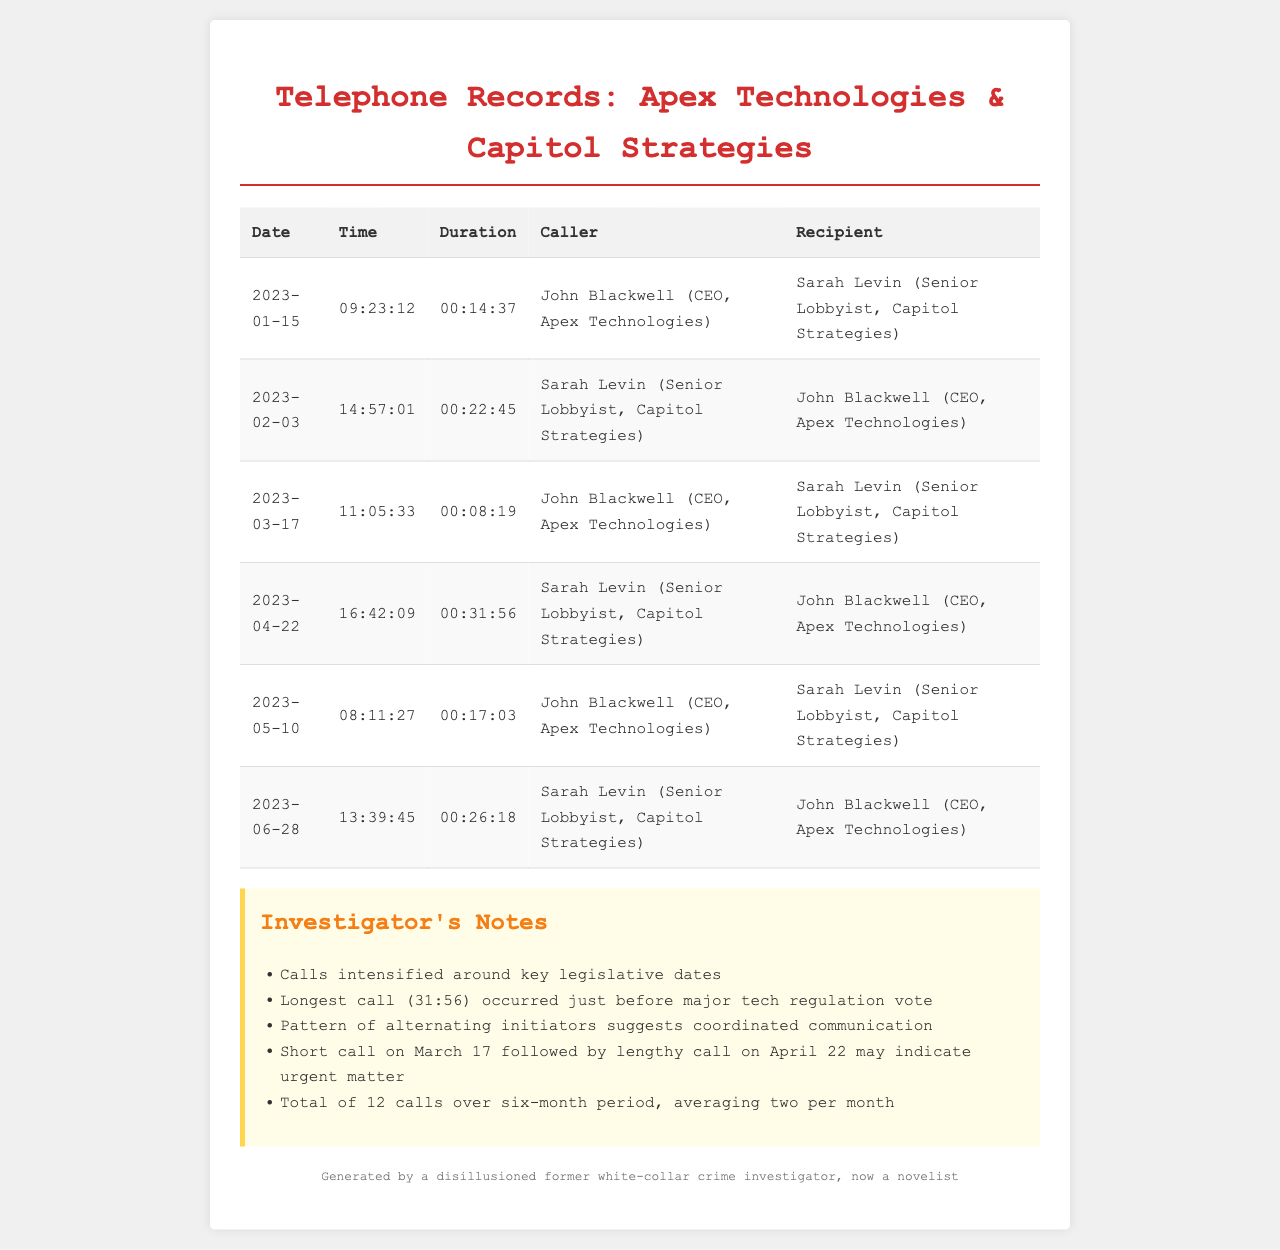What is the date of the longest call? The longest call lasted 31 minutes and 56 seconds, which occurred on April 22, 2023.
Answer: April 22, 2023 Who is the CEO of Apex Technologies? The document states that John Blackwell holds the title of CEO at Apex Technologies.
Answer: John Blackwell How many calls were made in total over the six-month period? The document mentions a total of 12 calls during the specified timeframe.
Answer: 12 What was the duration of the call on February 3? The duration of the call on February 3, 2023, is noted as 22 minutes and 45 seconds.
Answer: 00:22:45 Which party initiated the call on March 17? According to the log, John Blackwell initiated the call on March 17.
Answer: John Blackwell What pattern is noted regarding the call initiators? The notes highlight a pattern of alternating initiators, indicating coordinated communication between the parties.
Answer: Alternating initiators What was the average number of calls per month? Given the total of 12 calls over six months, the average number of calls per month is calculated in the notes.
Answer: 2 What role does Sarah Levin hold at Capitol Strategies? The document specifies that Sarah Levin is a Senior Lobbyist at Capitol Strategies.
Answer: Senior Lobbyist How long did the call on May 10 last? The log shows the call on May 10 lasted 17 minutes and 3 seconds.
Answer: 00:17:03 